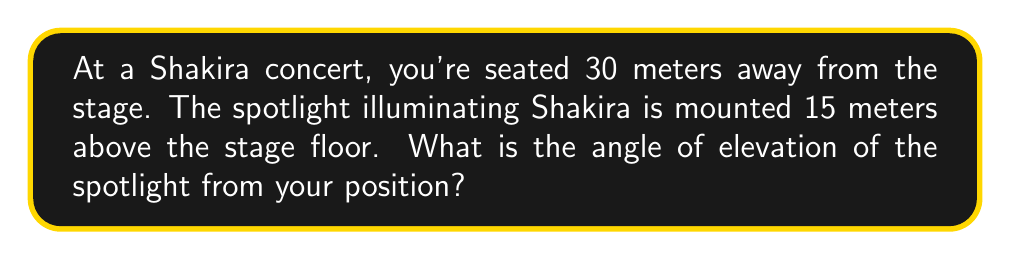What is the answer to this math problem? Let's approach this step-by-step:

1) We can visualize this as a right triangle, where:
   - The base of the triangle is the horizontal distance from you to the stage (30 m)
   - The height of the triangle is the height of the spotlight above the stage (15 m)
   - The hypotenuse is the line from your eyes to the spotlight
   - The angle we're looking for is the one formed between the base and the hypotenuse

2) This is a perfect scenario to use the tangent function. Recall that:

   $$\tan(\theta) = \frac{\text{opposite}}{\text{adjacent}}$$

3) In our case:
   - The opposite side is the height of the spotlight (15 m)
   - The adjacent side is your distance from the stage (30 m)

4) Let's plug these values into the tangent formula:

   $$\tan(\theta) = \frac{15}{30} = \frac{1}{2} = 0.5$$

5) To find the angle $\theta$, we need to use the inverse tangent (arctan or $\tan^{-1}$):

   $$\theta = \tan^{-1}(0.5)$$

6) Using a calculator or trigonometric tables:

   $$\theta \approx 26.57°$$

Thus, the angle of elevation of the spotlight is approximately 26.57 degrees.
Answer: $26.57°$ 